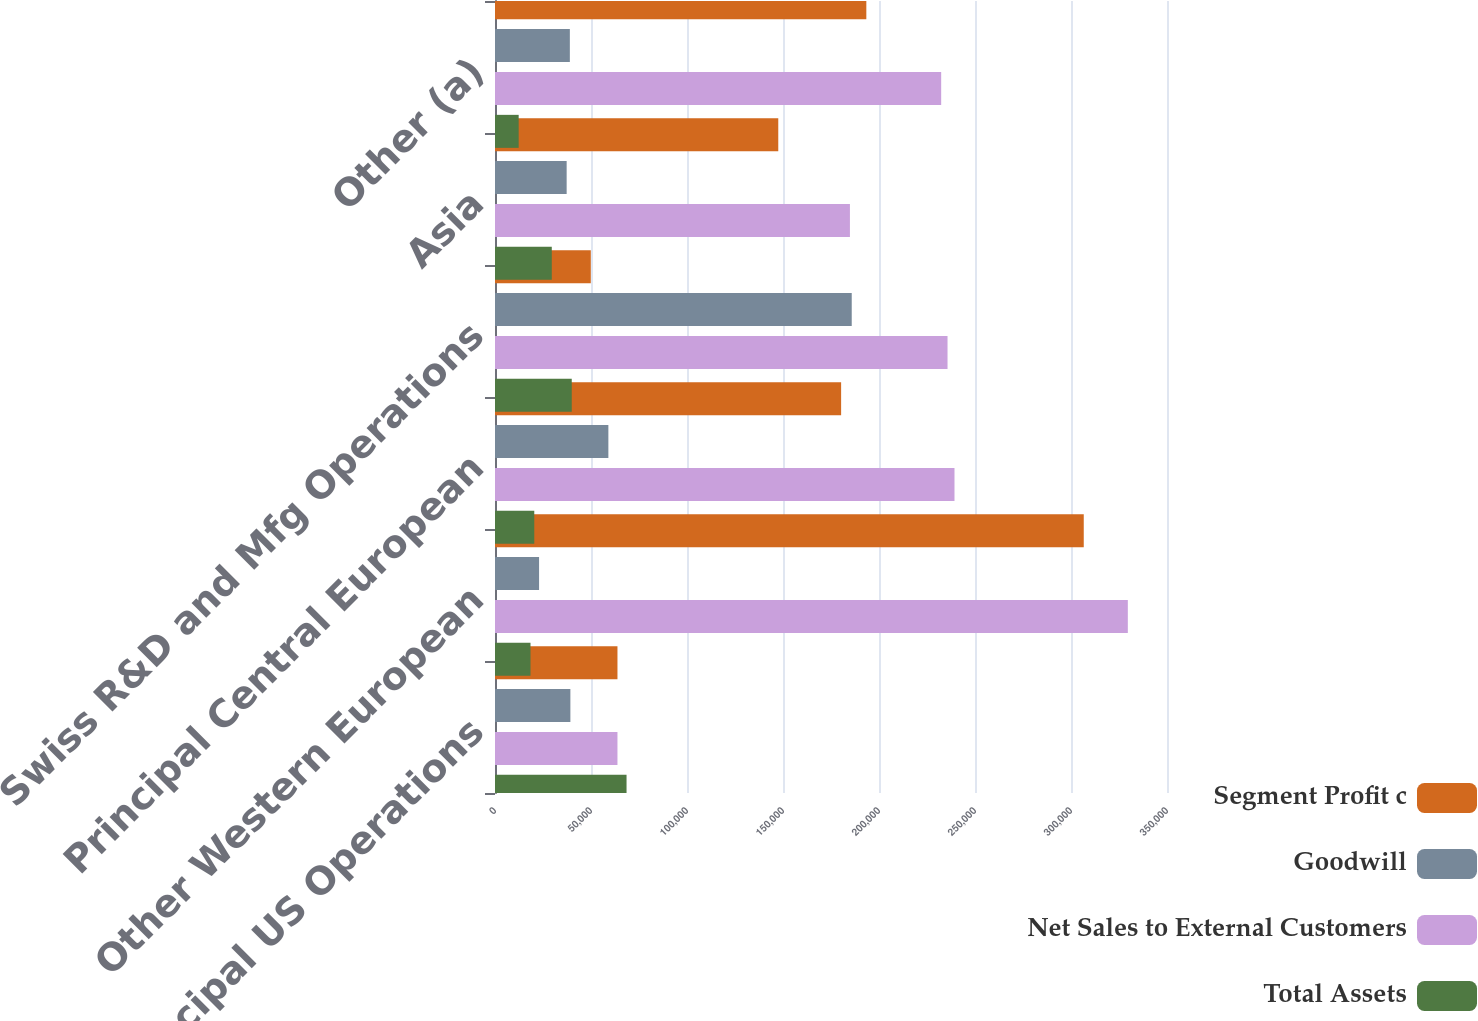<chart> <loc_0><loc_0><loc_500><loc_500><stacked_bar_chart><ecel><fcel>Principal US Operations<fcel>Other Western European<fcel>Principal Central European<fcel>Swiss R&D and Mfg Operations<fcel>Asia<fcel>Other (a)<nl><fcel>Segment Profit c<fcel>63782<fcel>306644<fcel>180272<fcel>49897<fcel>147537<fcel>193401<nl><fcel>Goodwill<fcel>39259<fcel>22954<fcel>59048<fcel>185798<fcel>37320<fcel>38984<nl><fcel>Net Sales to External Customers<fcel>63782<fcel>329598<fcel>239320<fcel>235695<fcel>184857<fcel>232385<nl><fcel>Total Assets<fcel>68516<fcel>18491<fcel>20453<fcel>39970<fcel>29575<fcel>12330<nl></chart> 